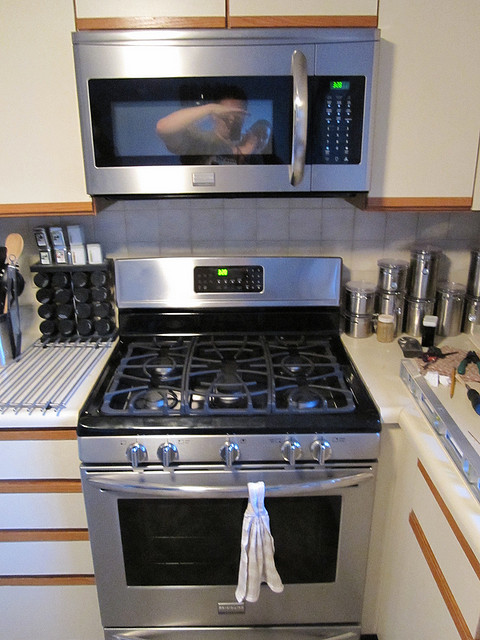Describe the items stored to the left of the stove. To the left of the stove, there is a set of stainless steel spice canisters lined up neatly in two rows and a knife block containing several knives for different culinary needs. 